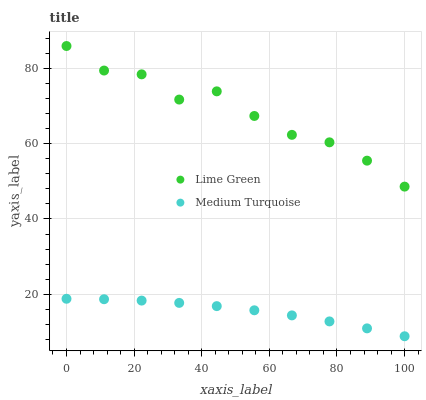Does Medium Turquoise have the minimum area under the curve?
Answer yes or no. Yes. Does Lime Green have the maximum area under the curve?
Answer yes or no. Yes. Does Medium Turquoise have the maximum area under the curve?
Answer yes or no. No. Is Medium Turquoise the smoothest?
Answer yes or no. Yes. Is Lime Green the roughest?
Answer yes or no. Yes. Is Medium Turquoise the roughest?
Answer yes or no. No. Does Medium Turquoise have the lowest value?
Answer yes or no. Yes. Does Lime Green have the highest value?
Answer yes or no. Yes. Does Medium Turquoise have the highest value?
Answer yes or no. No. Is Medium Turquoise less than Lime Green?
Answer yes or no. Yes. Is Lime Green greater than Medium Turquoise?
Answer yes or no. Yes. Does Medium Turquoise intersect Lime Green?
Answer yes or no. No. 